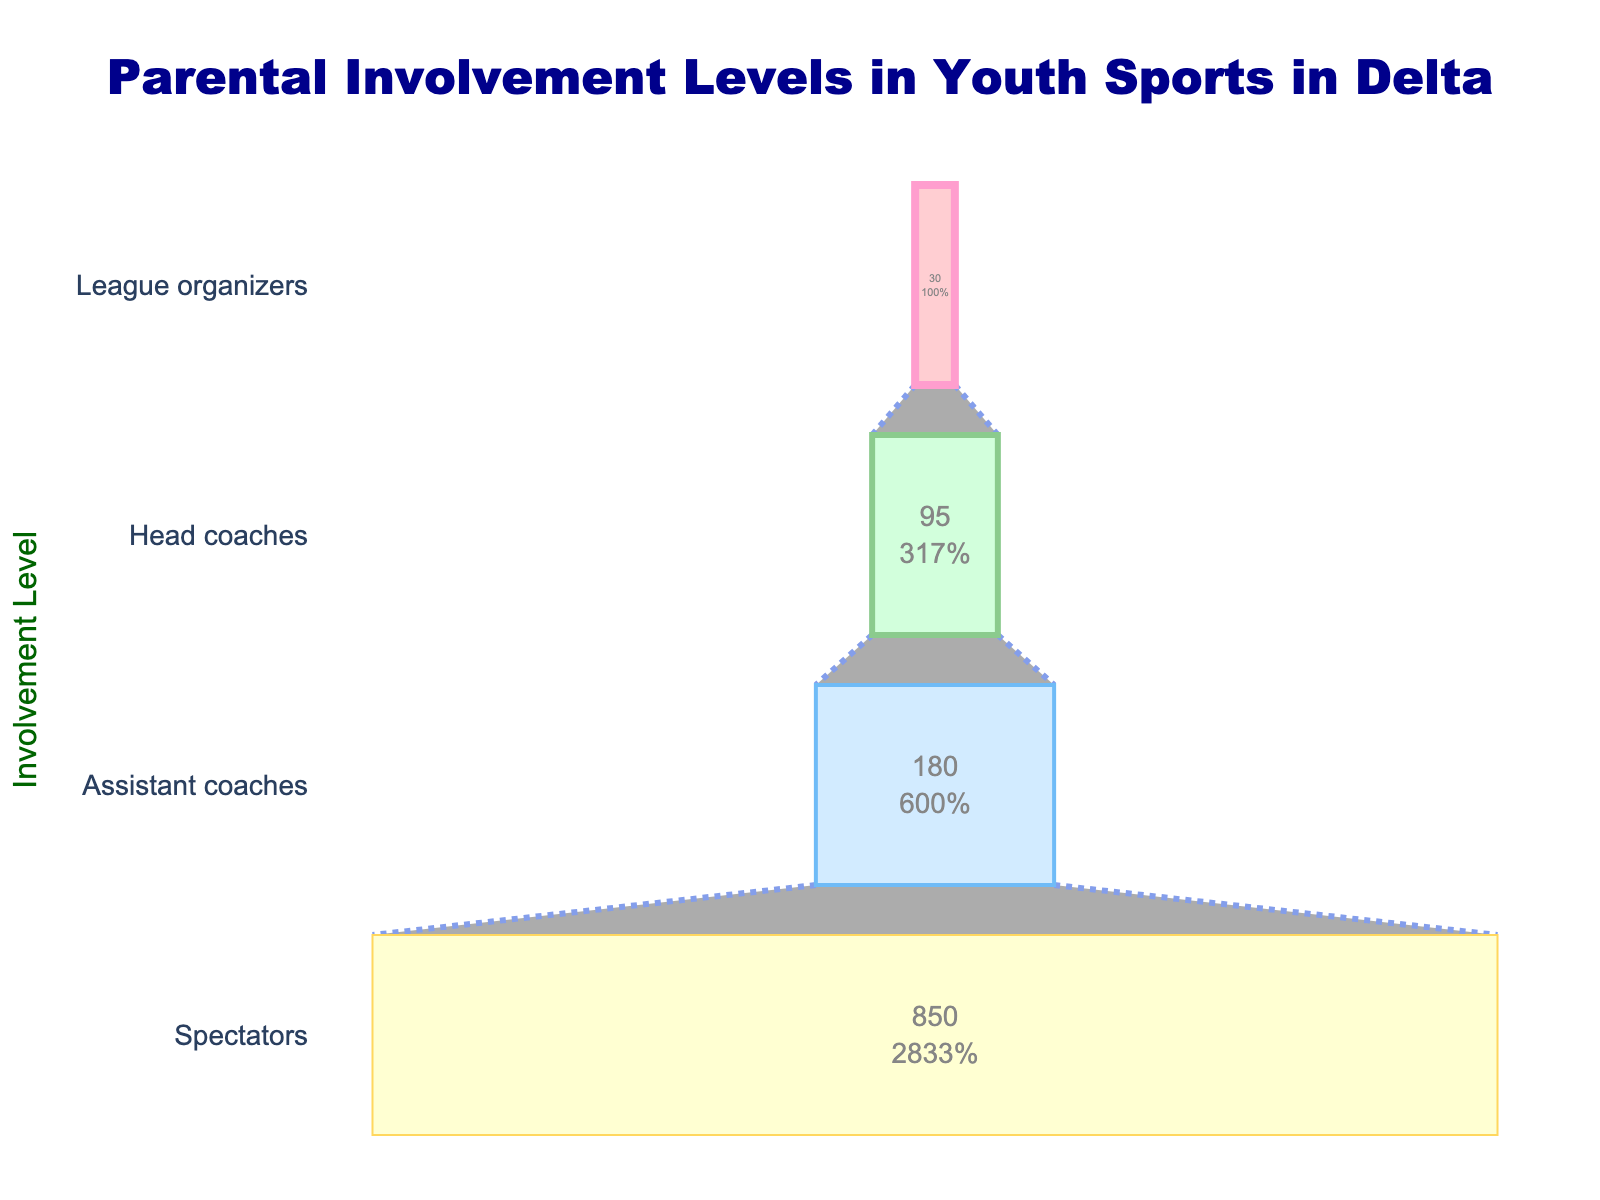What is the title of the funnel chart? The funnel chart's title can be found at the top of the chart. It reads, "Parental Involvement Levels in Youth Sports in Delta."
Answer: Parental Involvement Levels in Youth Sports in Delta Which stage has the highest number of parents involved? The funnel chart shows four stages with the number of parents involved at each stage. The stage with the highest number of parents is the first one, "Spectators," which has 850 parents.
Answer: Spectators How many parents are involved as assistant coaches and head coaches combined? To find this, add the number of parents involved as assistant coaches (180) to the number of parents involved as head coaches (95). 180 + 95 = 275.
Answer: 275 What is the difference in the number of parents between head coaches and league organizers? Subtract the number of league organizers (30) from the number of head coaches (95) to find the difference. 95 - 30 = 65.
Answer: 65 Which role has the least number of parents involved? The funnel chart shows that the role with the least number of parents involved is the "League organizers" stage, with 30 parents.
Answer: League organizers Are there more parents acting as spectators or assistant coaches? Compare the numbers: the chart shows 850 parents as spectators and 180 as assistant coaches. 850 is greater than 180.
Answer: Spectators What percentage of the initial group (spectators) are involved as head coaches? First, find the number of head coaches (95) and the number of spectators (850). Then, use the formula: (number of head coaches / number of spectators) * 100. (95 / 850) * 100 ≈ 11.18%.
Answer: ~11.18% By how much does the number of parents drop from spectators to assistant coaches? Subtract the number of assistant coaches (180) from the number of spectators (850). 850 - 180 = 670.
Answer: 670 What percentages of the initial number of parents are involved in each of the stages (assistant coaches, head coaches, and league organizers)? 1. Assistant coaches: (180 / 850) * 100 ≈ 21.18%
2. Head coaches: (95 / 850) * 100 ≈ 11.18%
3. League organizers: (30 / 850) * 100 ≈ 3.53%
Answer: Assistant coaches: ~21.18%, Head coaches: ~11.18%, League organizers: ~3.53% 